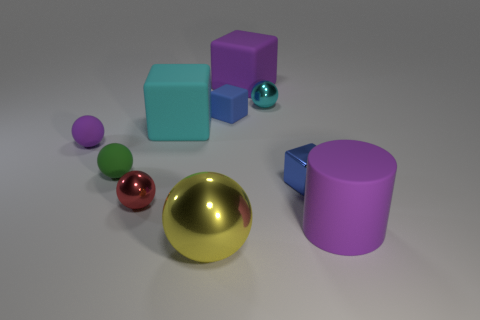Is the color of the big matte cylinder the same as the big sphere?
Ensure brevity in your answer.  No. What number of matte things are either cyan balls or small cylinders?
Offer a very short reply. 0. How many red shiny cylinders are there?
Give a very brief answer. 0. Is the material of the big object that is in front of the rubber cylinder the same as the tiny blue object that is right of the tiny rubber block?
Make the answer very short. Yes. What is the color of the other small metal object that is the same shape as the small red thing?
Keep it short and to the point. Cyan. There is a object that is in front of the big purple matte thing right of the small shiny cube; what is its material?
Your answer should be very brief. Metal. Does the tiny blue object that is to the right of the purple matte block have the same shape as the big purple matte object that is on the left side of the big purple cylinder?
Provide a succinct answer. Yes. What is the size of the object that is to the right of the purple rubber block and in front of the tiny metallic cube?
Offer a very short reply. Large. What number of other things are there of the same color as the large matte cylinder?
Provide a succinct answer. 2. Are there an equal number of large red metallic balls and tiny green rubber spheres?
Ensure brevity in your answer.  No. 